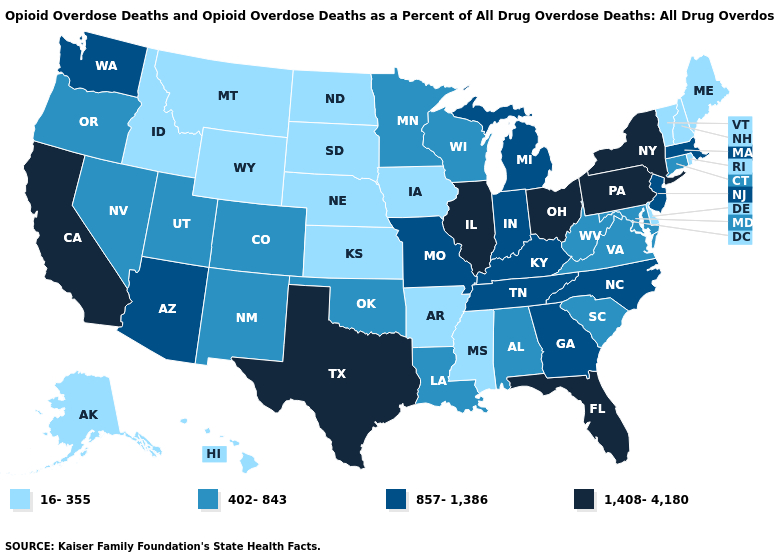Is the legend a continuous bar?
Give a very brief answer. No. Name the states that have a value in the range 857-1,386?
Concise answer only. Arizona, Georgia, Indiana, Kentucky, Massachusetts, Michigan, Missouri, New Jersey, North Carolina, Tennessee, Washington. What is the highest value in states that border Colorado?
Give a very brief answer. 857-1,386. Does California have the lowest value in the West?
Write a very short answer. No. What is the highest value in states that border West Virginia?
Concise answer only. 1,408-4,180. What is the value of Ohio?
Write a very short answer. 1,408-4,180. What is the value of Minnesota?
Concise answer only. 402-843. Is the legend a continuous bar?
Concise answer only. No. What is the lowest value in the USA?
Keep it brief. 16-355. Does the map have missing data?
Give a very brief answer. No. Name the states that have a value in the range 16-355?
Concise answer only. Alaska, Arkansas, Delaware, Hawaii, Idaho, Iowa, Kansas, Maine, Mississippi, Montana, Nebraska, New Hampshire, North Dakota, Rhode Island, South Dakota, Vermont, Wyoming. Does the map have missing data?
Keep it brief. No. Name the states that have a value in the range 1,408-4,180?
Give a very brief answer. California, Florida, Illinois, New York, Ohio, Pennsylvania, Texas. What is the value of Maryland?
Give a very brief answer. 402-843. 